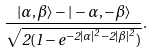<formula> <loc_0><loc_0><loc_500><loc_500>\frac { | \alpha , \beta \rangle - | - \alpha , - \beta \rangle } { \sqrt { 2 ( 1 - e ^ { - 2 | \alpha | ^ { 2 } - 2 | \beta | ^ { 2 } } ) } } .</formula> 